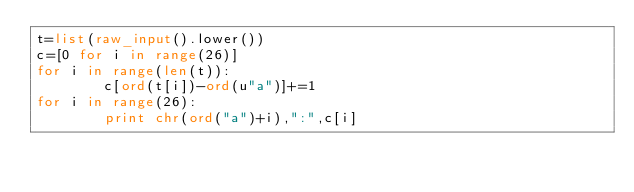<code> <loc_0><loc_0><loc_500><loc_500><_Python_>t=list(raw_input().lower())
c=[0 for i in range(26)]
for i in range(len(t)):
        c[ord(t[i])-ord(u"a")]+=1
for i in range(26):
        print chr(ord("a")+i),":",c[i]</code> 